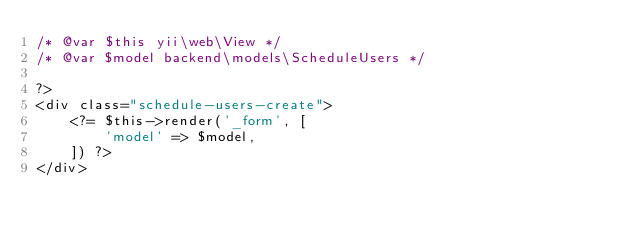Convert code to text. <code><loc_0><loc_0><loc_500><loc_500><_PHP_>/* @var $this yii\web\View */
/* @var $model backend\models\ScheduleUsers */

?>
<div class="schedule-users-create">
    <?= $this->render('_form', [
        'model' => $model,
    ]) ?>
</div>
</code> 